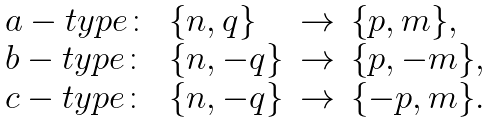<formula> <loc_0><loc_0><loc_500><loc_500>\begin{array} { l l c l } a - t y p e \colon & \{ n , q \} & \rightarrow & \{ p , m \} , \\ b - t y p e \colon & \{ n , - q \} & \rightarrow & \{ p , - m \} , \\ c - t y p e \colon & \{ n , - q \} & \rightarrow & \{ - p , m \} . \end{array}</formula> 